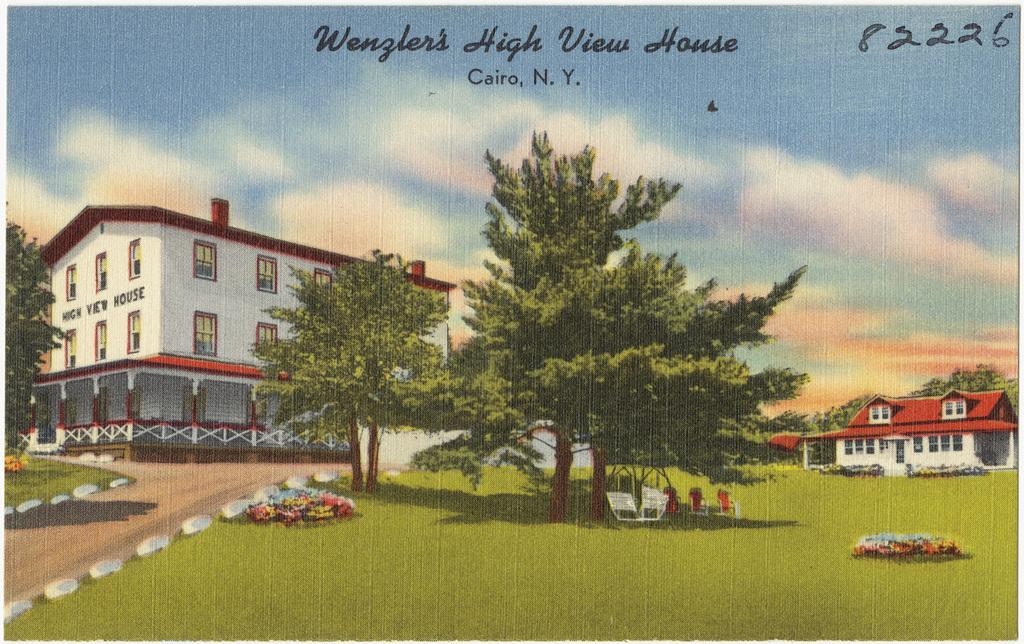What is the main subject of the image? There is a painting in the image. What can be seen in the background of the painting? There are trees and buildings in the backdrop of the image. What is the condition of the sky in the image? The sky is clear in the image. Can you see a horse wearing a crown in the image? There is no horse or crown present in the image; it features a painting with trees, buildings, and a clear sky. 